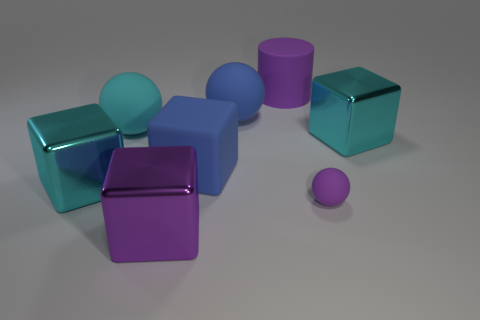What is the shape of the small object that is the same color as the matte cylinder?
Offer a very short reply. Sphere. Are the cyan ball and the blue block made of the same material?
Your answer should be very brief. Yes. Are there more large rubber cylinders on the right side of the tiny purple thing than big matte things?
Offer a terse response. No. What material is the cube that is right of the large purple thing that is behind the cyan block that is behind the large rubber cube?
Keep it short and to the point. Metal. How many things are either big cyan blocks or big blue rubber cubes on the right side of the purple shiny object?
Your answer should be compact. 3. There is a ball in front of the rubber cube; does it have the same color as the cylinder?
Offer a very short reply. Yes. Are there more large purple objects to the right of the large matte cylinder than large metallic things to the right of the tiny rubber ball?
Ensure brevity in your answer.  No. Are there any other things that have the same color as the small ball?
Your response must be concise. Yes. What number of things are big cyan matte objects or small purple matte things?
Provide a succinct answer. 2. There is a metal thing that is left of the cyan sphere; is its size the same as the cyan ball?
Provide a short and direct response. Yes. 